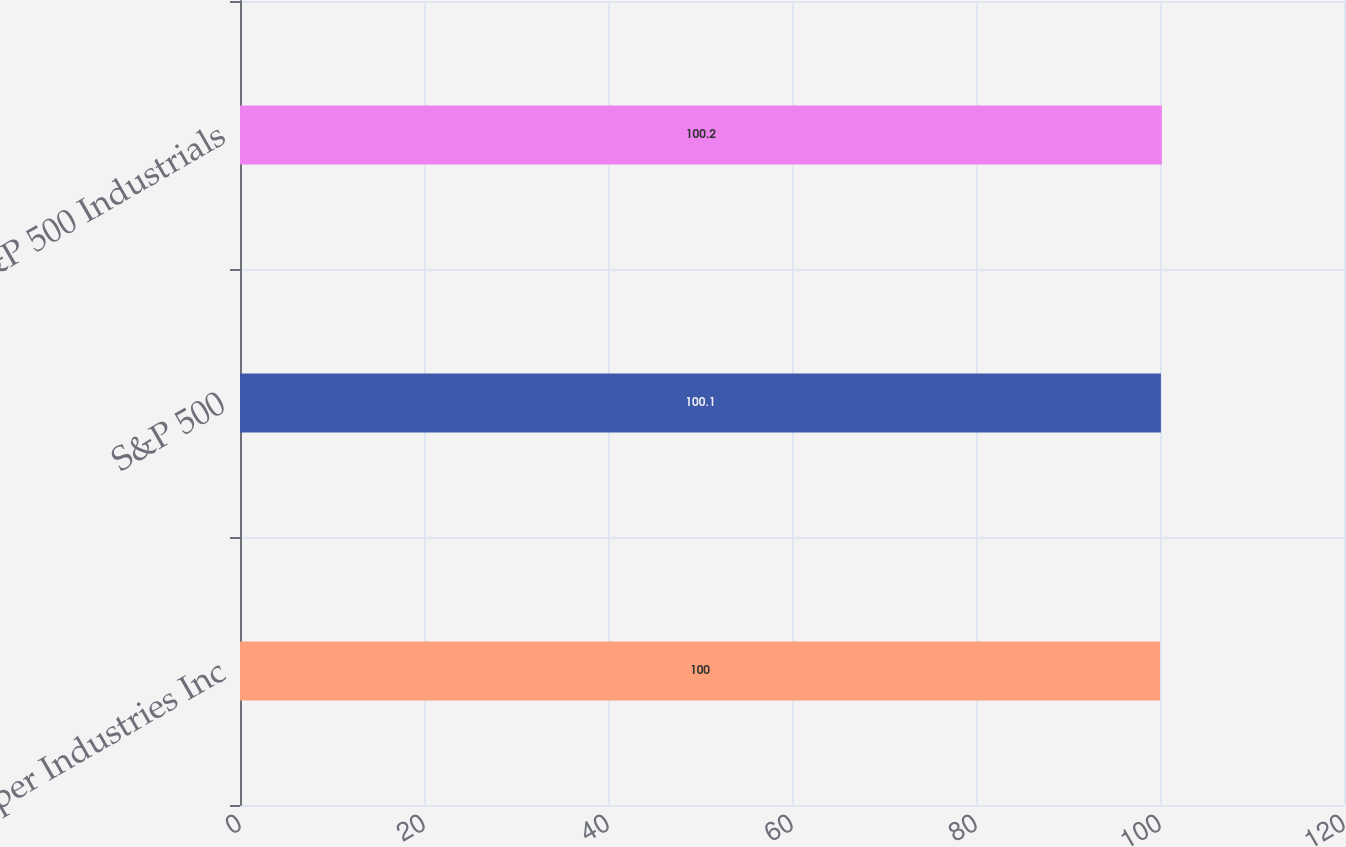<chart> <loc_0><loc_0><loc_500><loc_500><bar_chart><fcel>Roper Industries Inc<fcel>S&P 500<fcel>S&P 500 Industrials<nl><fcel>100<fcel>100.1<fcel>100.2<nl></chart> 